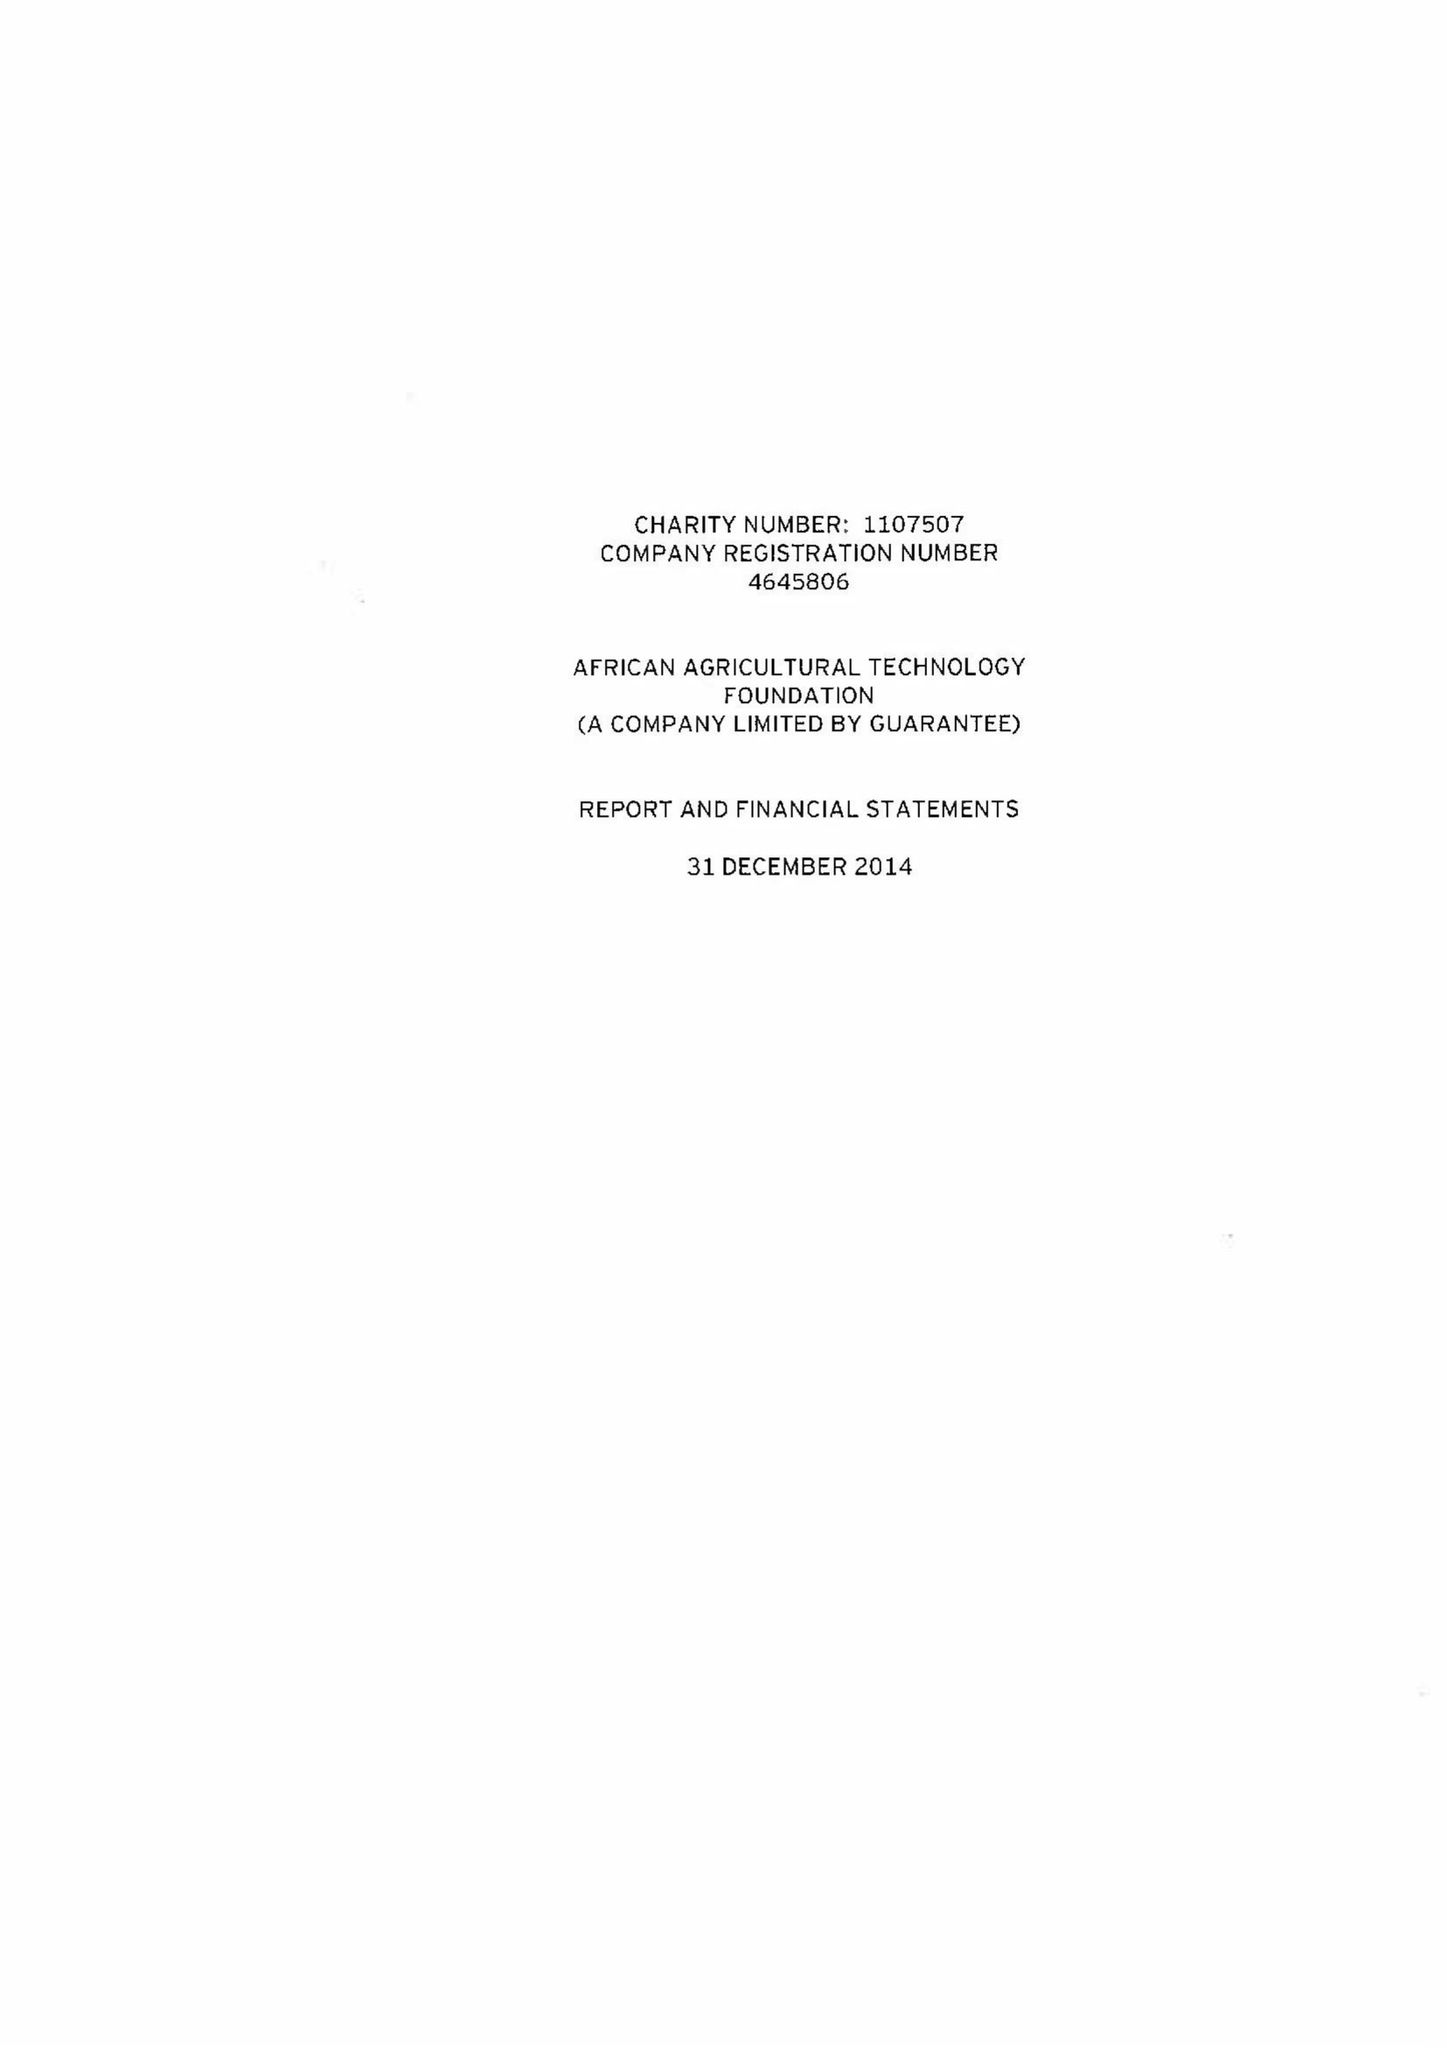What is the value for the spending_annually_in_british_pounds?
Answer the question using a single word or phrase. 15913011.00 